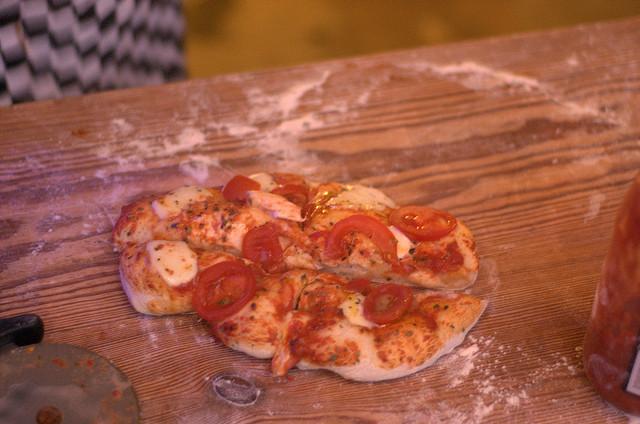Are those tomatoes on the pizza?
Short answer required. Yes. What is the tabletop made of?
Keep it brief. Wood. What are the red slices on the pizza?
Keep it brief. Tomatoes. 